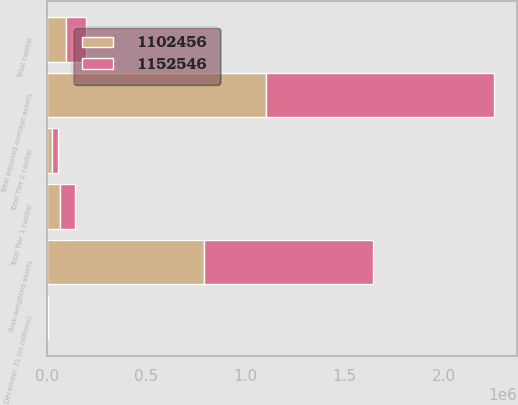<chart> <loc_0><loc_0><loc_500><loc_500><stacked_bar_chart><ecel><fcel>December 31 (in millions)<fcel>Total Tier 1 capital<fcel>Total Tier 2 capital<fcel>Total capital<fcel>Risk-weighted assets<fcel>Total adjusted average assets<nl><fcel>1.15255e+06<fcel>2005<fcel>72474<fcel>29963<fcel>102437<fcel>850643<fcel>1.15255e+06<nl><fcel>1.10246e+06<fcel>2004<fcel>68621<fcel>28186<fcel>96807<fcel>791373<fcel>1.10246e+06<nl></chart> 